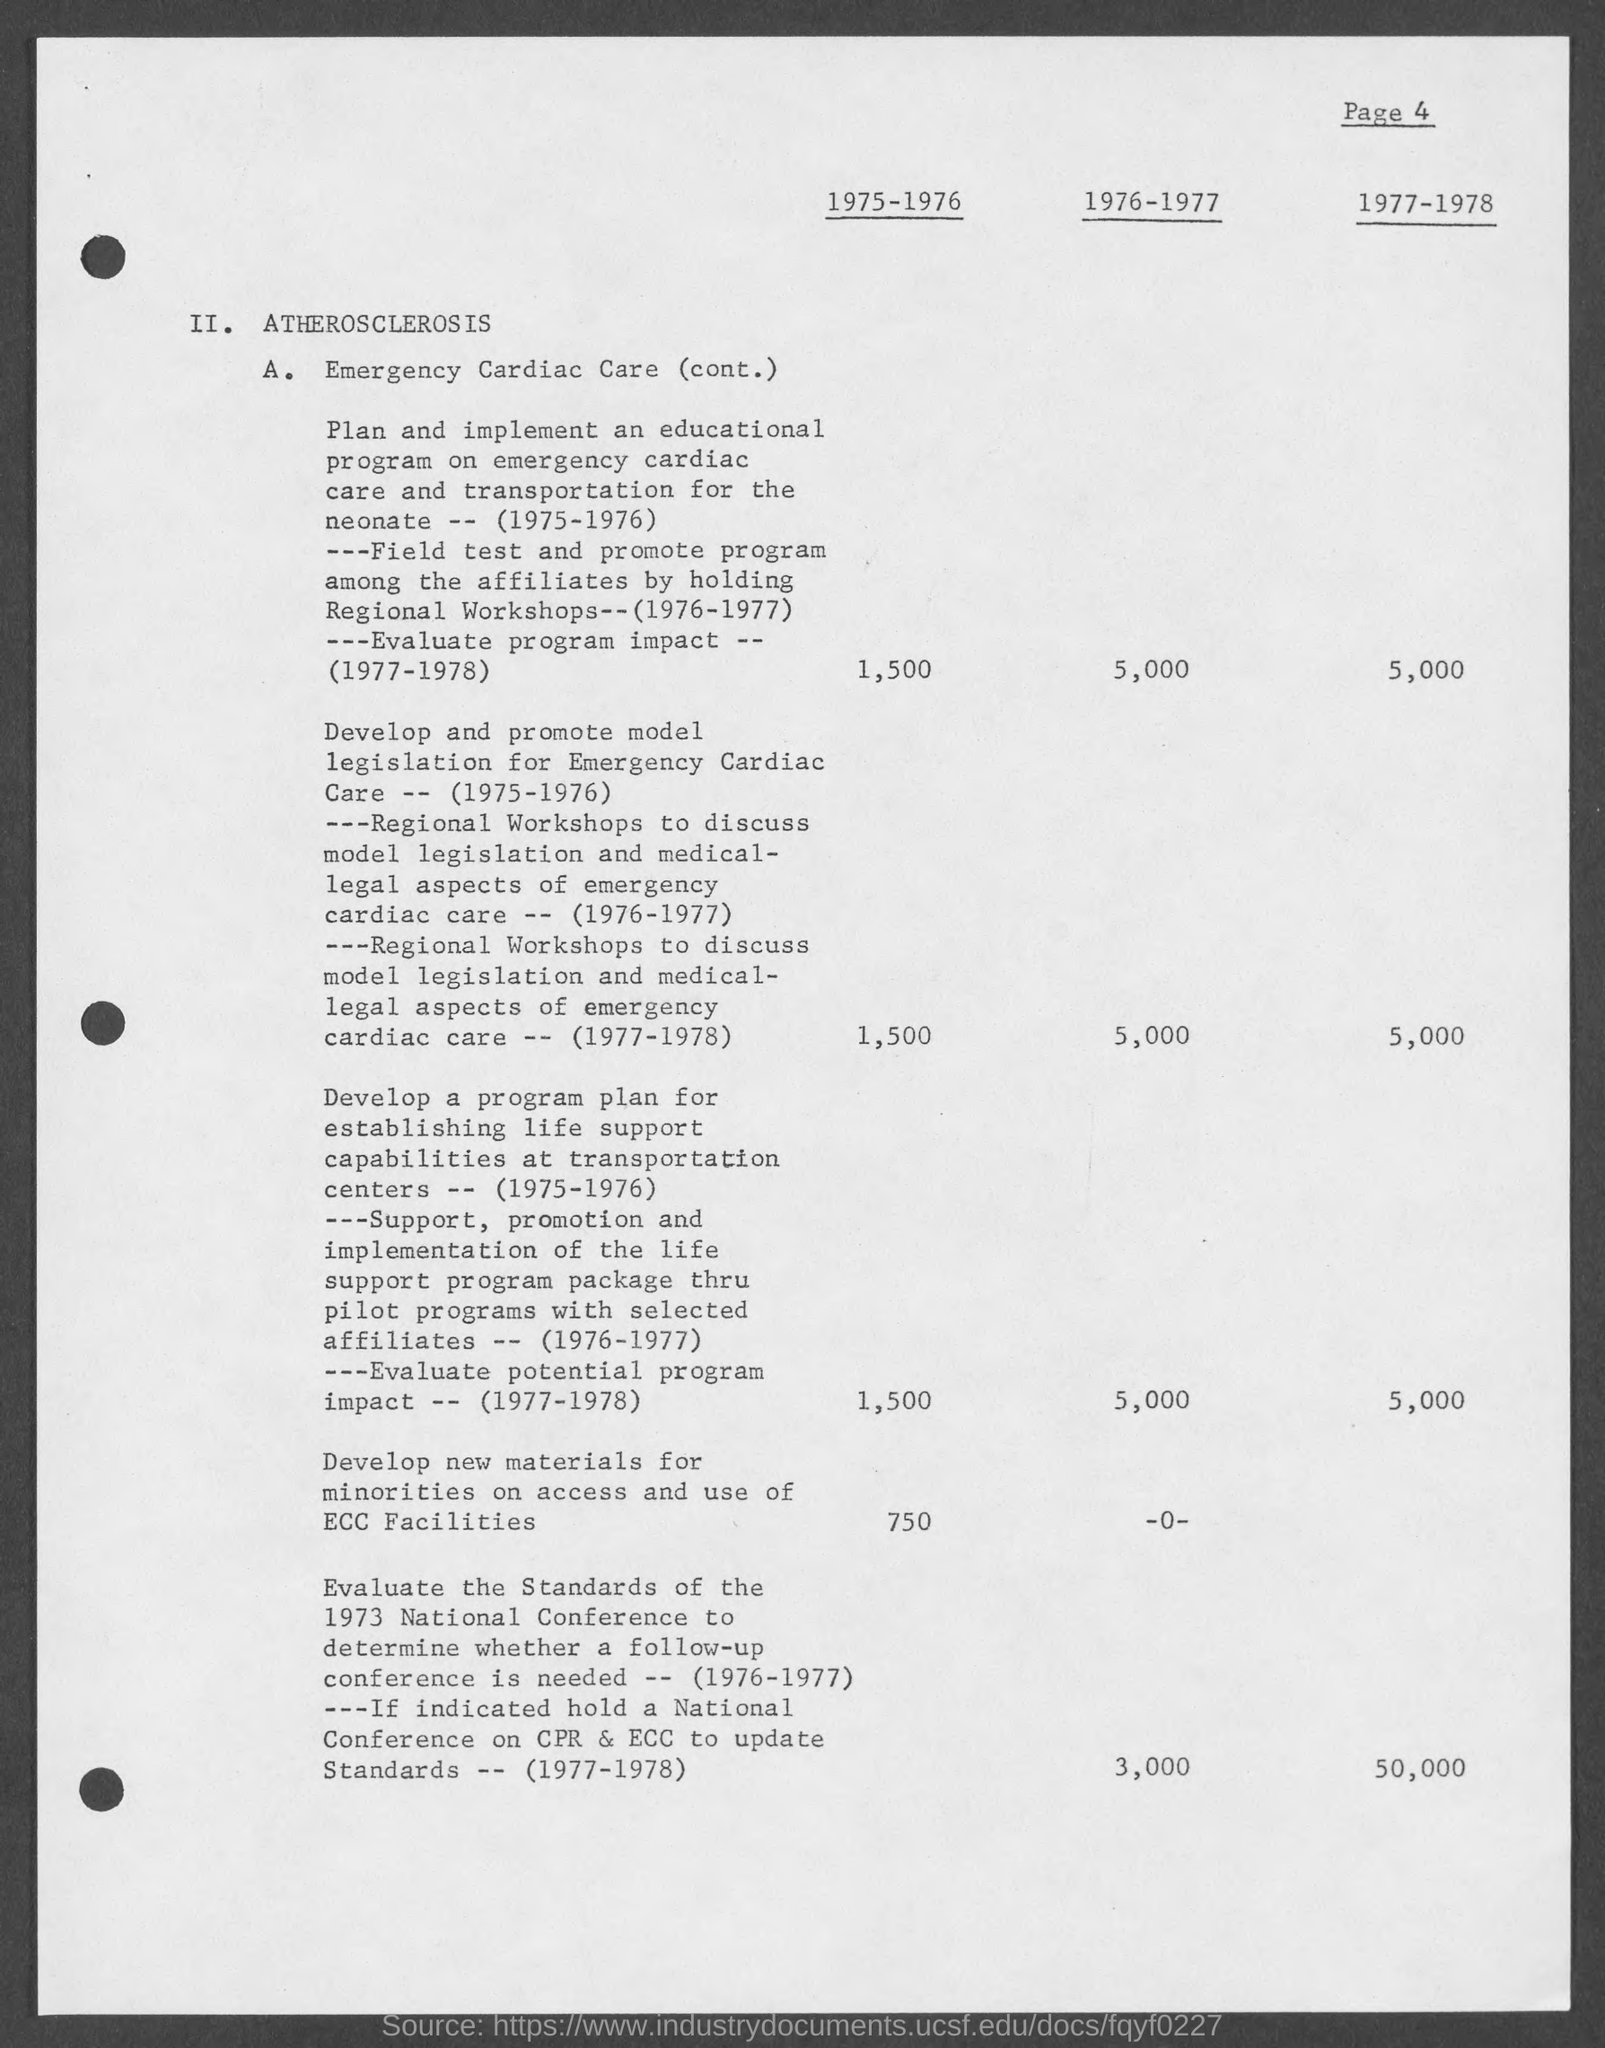What is the page number at top of the page?
Your answer should be compact. 4. What is the heading of document on top?
Your answer should be compact. Atherosclerosis. 